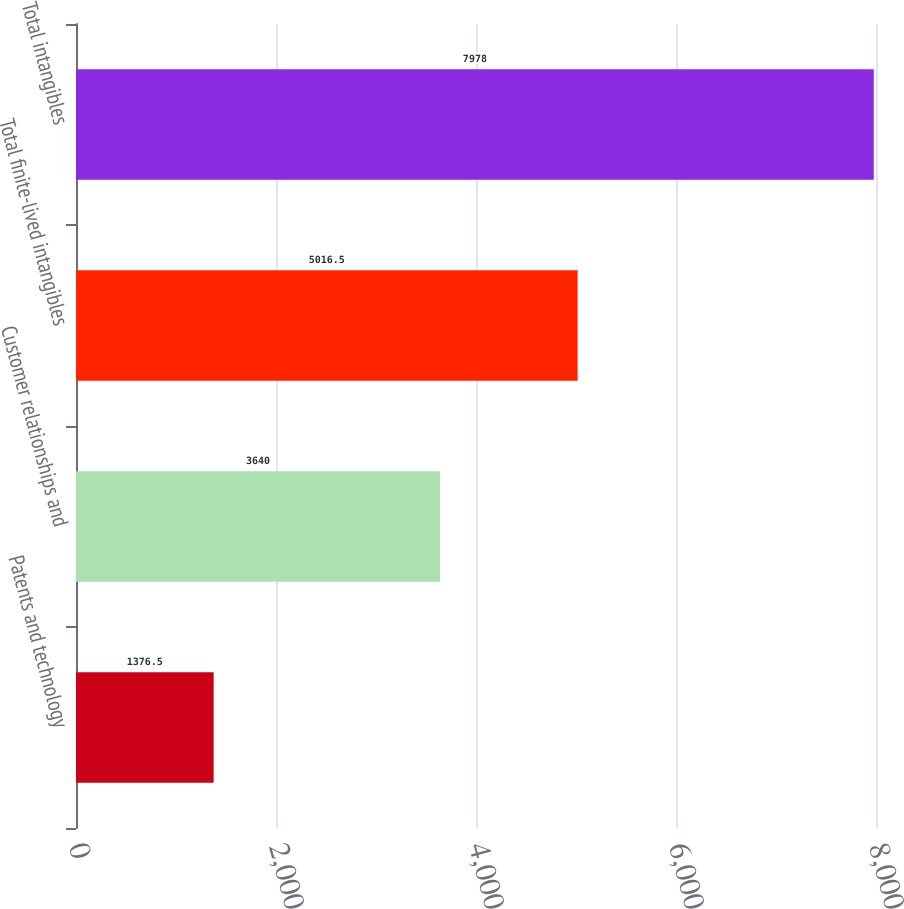<chart> <loc_0><loc_0><loc_500><loc_500><bar_chart><fcel>Patents and technology<fcel>Customer relationships and<fcel>Total finite-lived intangibles<fcel>Total intangibles<nl><fcel>1376.5<fcel>3640<fcel>5016.5<fcel>7978<nl></chart> 